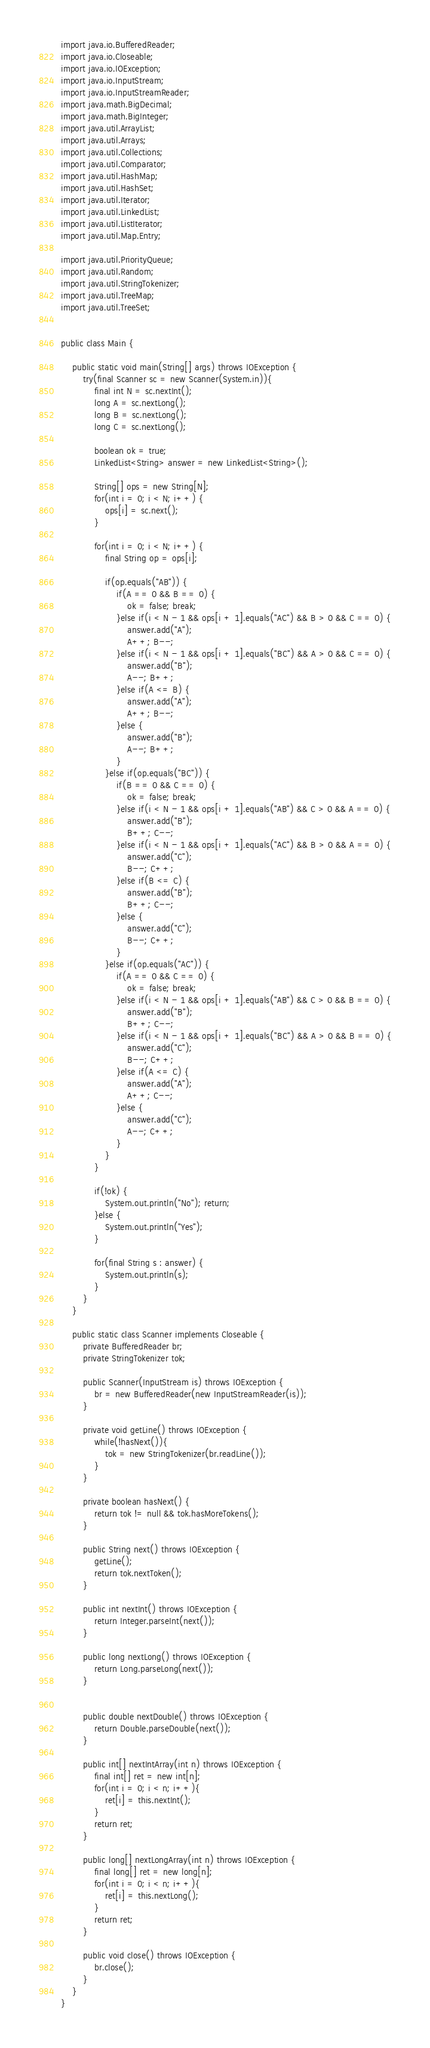<code> <loc_0><loc_0><loc_500><loc_500><_Java_>import java.io.BufferedReader;
import java.io.Closeable;
import java.io.IOException;
import java.io.InputStream;
import java.io.InputStreamReader;
import java.math.BigDecimal;
import java.math.BigInteger;
import java.util.ArrayList;
import java.util.Arrays;
import java.util.Collections;
import java.util.Comparator;
import java.util.HashMap;
import java.util.HashSet;
import java.util.Iterator;
import java.util.LinkedList;
import java.util.ListIterator;
import java.util.Map.Entry;

import java.util.PriorityQueue;
import java.util.Random;
import java.util.StringTokenizer;
import java.util.TreeMap;
import java.util.TreeSet;


public class Main {
	
	public static void main(String[] args) throws IOException {	
		try(final Scanner sc = new Scanner(System.in)){
			final int N = sc.nextInt();
			long A = sc.nextLong();
			long B = sc.nextLong();
			long C = sc.nextLong();
			
			boolean ok = true;
			LinkedList<String> answer = new LinkedList<String>();
			
			String[] ops = new String[N];
			for(int i = 0; i < N; i++) {
				ops[i] = sc.next();
			}
			
			for(int i = 0; i < N; i++) {
				final String op = ops[i];
				
				if(op.equals("AB")) {
					if(A == 0 && B == 0) {
						ok = false; break;
					}else if(i < N - 1 && ops[i + 1].equals("AC") && B > 0 && C == 0) {
						answer.add("A");
						A++; B--;
					}else if(i < N - 1 && ops[i + 1].equals("BC") && A > 0 && C == 0) {
						answer.add("B");
						A--; B++;
					}else if(A <= B) {
						answer.add("A");
						A++; B--;
					}else {
						answer.add("B");
						A--; B++;
					}
				}else if(op.equals("BC")) {
					if(B == 0 && C == 0) {
						ok = false; break;
					}else if(i < N - 1 && ops[i + 1].equals("AB") && C > 0 && A == 0) {
						answer.add("B");
						B++; C--;
					}else if(i < N - 1 && ops[i + 1].equals("AC") && B > 0 && A == 0) {
						answer.add("C");
						B--; C++;
					}else if(B <= C) {
						answer.add("B");
						B++; C--;
					}else {
						answer.add("C");
						B--; C++;
					}
				}else if(op.equals("AC")) {
					if(A == 0 && C == 0) {
						ok = false; break;
					}else if(i < N - 1 && ops[i + 1].equals("AB") && C > 0 && B == 0) {
						answer.add("B");
						B++; C--;
					}else if(i < N - 1 && ops[i + 1].equals("BC") && A > 0 && B == 0) {
						answer.add("C");
						B--; C++;
					}else if(A <= C) {
						answer.add("A");
						A++; C--;
					}else {
						answer.add("C");
						A--; C++;
					}
				}
			}
			
			if(!ok) {
				System.out.println("No"); return;
			}else {
				System.out.println("Yes");
			}
			
			for(final String s : answer) {
				System.out.println(s);
			}
		}
	}

	public static class Scanner implements Closeable {
		private BufferedReader br;
		private StringTokenizer tok;

		public Scanner(InputStream is) throws IOException {
			br = new BufferedReader(new InputStreamReader(is));
		}

		private void getLine() throws IOException {
			while(!hasNext()){
				tok = new StringTokenizer(br.readLine());
			}
		}

		private boolean hasNext() {
			return tok != null && tok.hasMoreTokens();
		}

		public String next() throws IOException {
			getLine();
			return tok.nextToken();
		}

		public int nextInt() throws IOException {
			return Integer.parseInt(next());
		}

		public long nextLong() throws IOException {
			return Long.parseLong(next());
		}
		

		public double nextDouble() throws IOException {
			return Double.parseDouble(next());
		}

		public int[] nextIntArray(int n) throws IOException {
			final int[] ret = new int[n];
			for(int i = 0; i < n; i++){
				ret[i] = this.nextInt();
			}
			return ret;
		}

		public long[] nextLongArray(int n) throws IOException {
			final long[] ret = new long[n];
			for(int i = 0; i < n; i++){
				ret[i] = this.nextLong();
			}
			return ret;
		}

		public void close() throws IOException {
			br.close();
		}
	}
}
</code> 